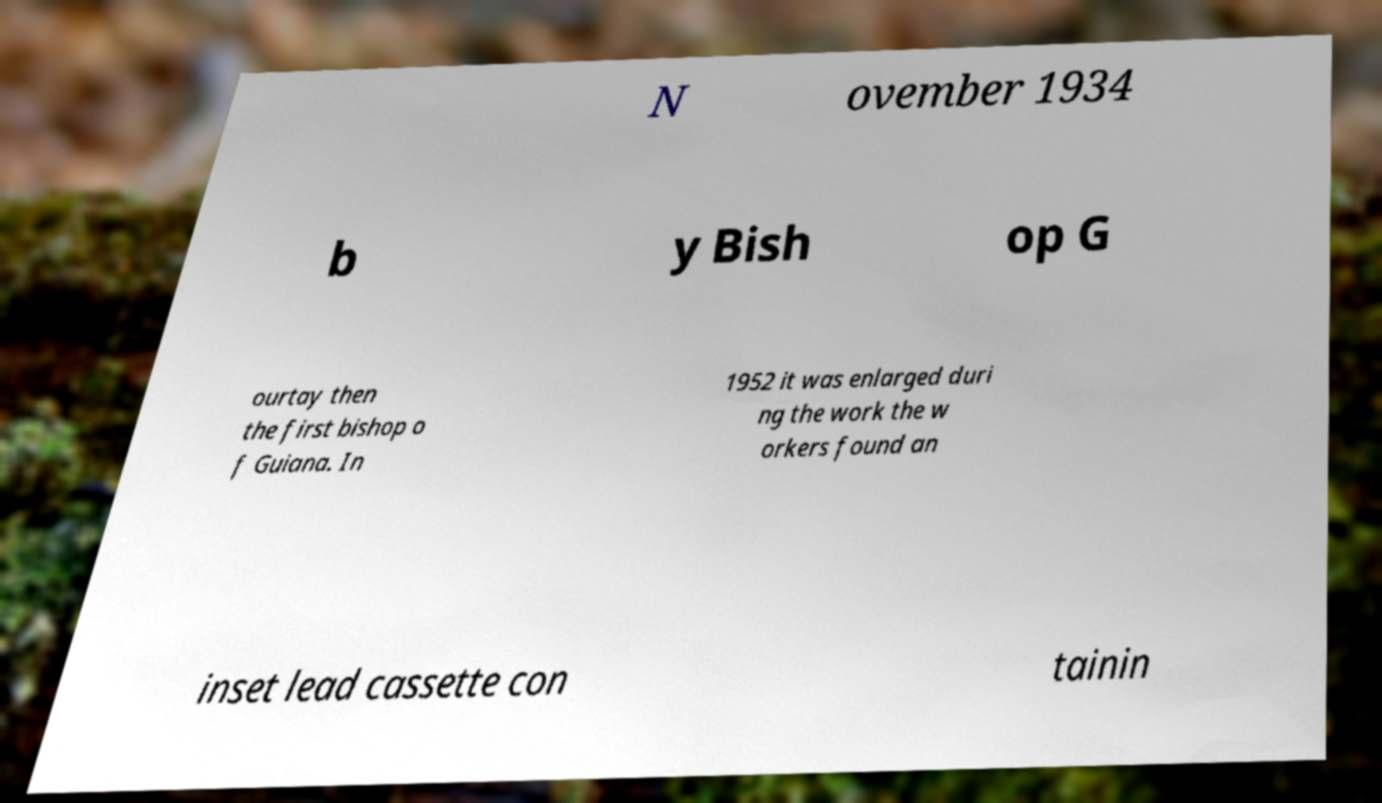Can you read and provide the text displayed in the image?This photo seems to have some interesting text. Can you extract and type it out for me? N ovember 1934 b y Bish op G ourtay then the first bishop o f Guiana. In 1952 it was enlarged duri ng the work the w orkers found an inset lead cassette con tainin 